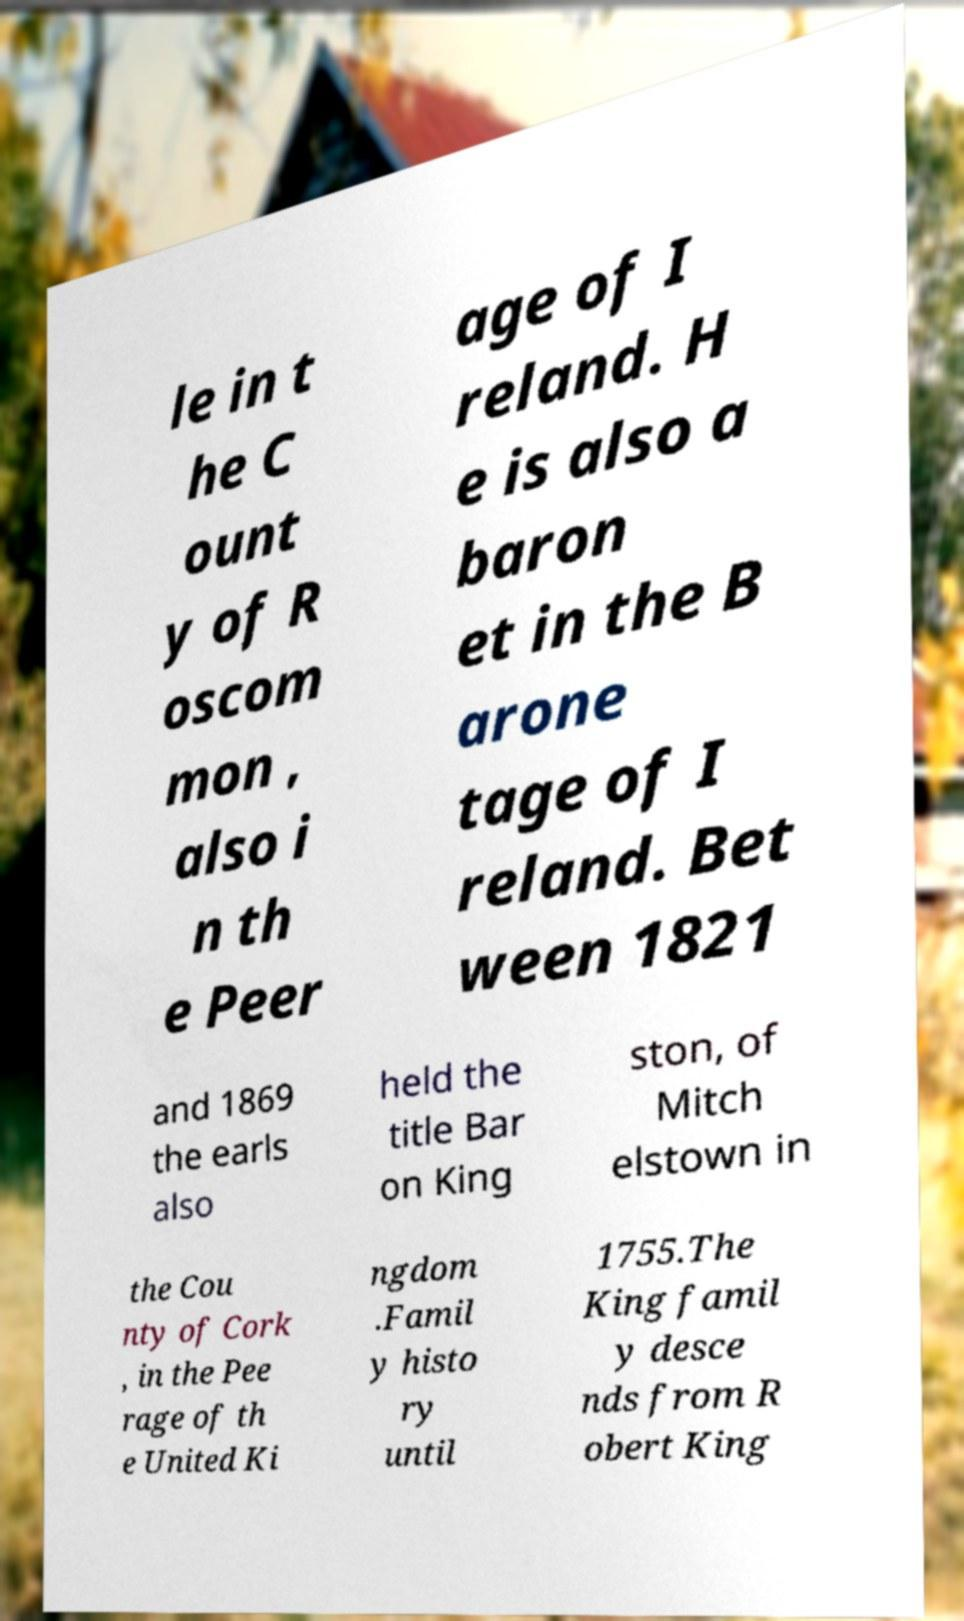Please read and relay the text visible in this image. What does it say? le in t he C ount y of R oscom mon , also i n th e Peer age of I reland. H e is also a baron et in the B arone tage of I reland. Bet ween 1821 and 1869 the earls also held the title Bar on King ston, of Mitch elstown in the Cou nty of Cork , in the Pee rage of th e United Ki ngdom .Famil y histo ry until 1755.The King famil y desce nds from R obert King 